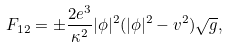<formula> <loc_0><loc_0><loc_500><loc_500>F _ { 1 2 } = \pm \frac { 2 e ^ { 3 } } { \kappa ^ { 2 } } | \phi | ^ { 2 } ( | \phi | ^ { 2 } - v ^ { 2 } ) \sqrt { g } ,</formula> 